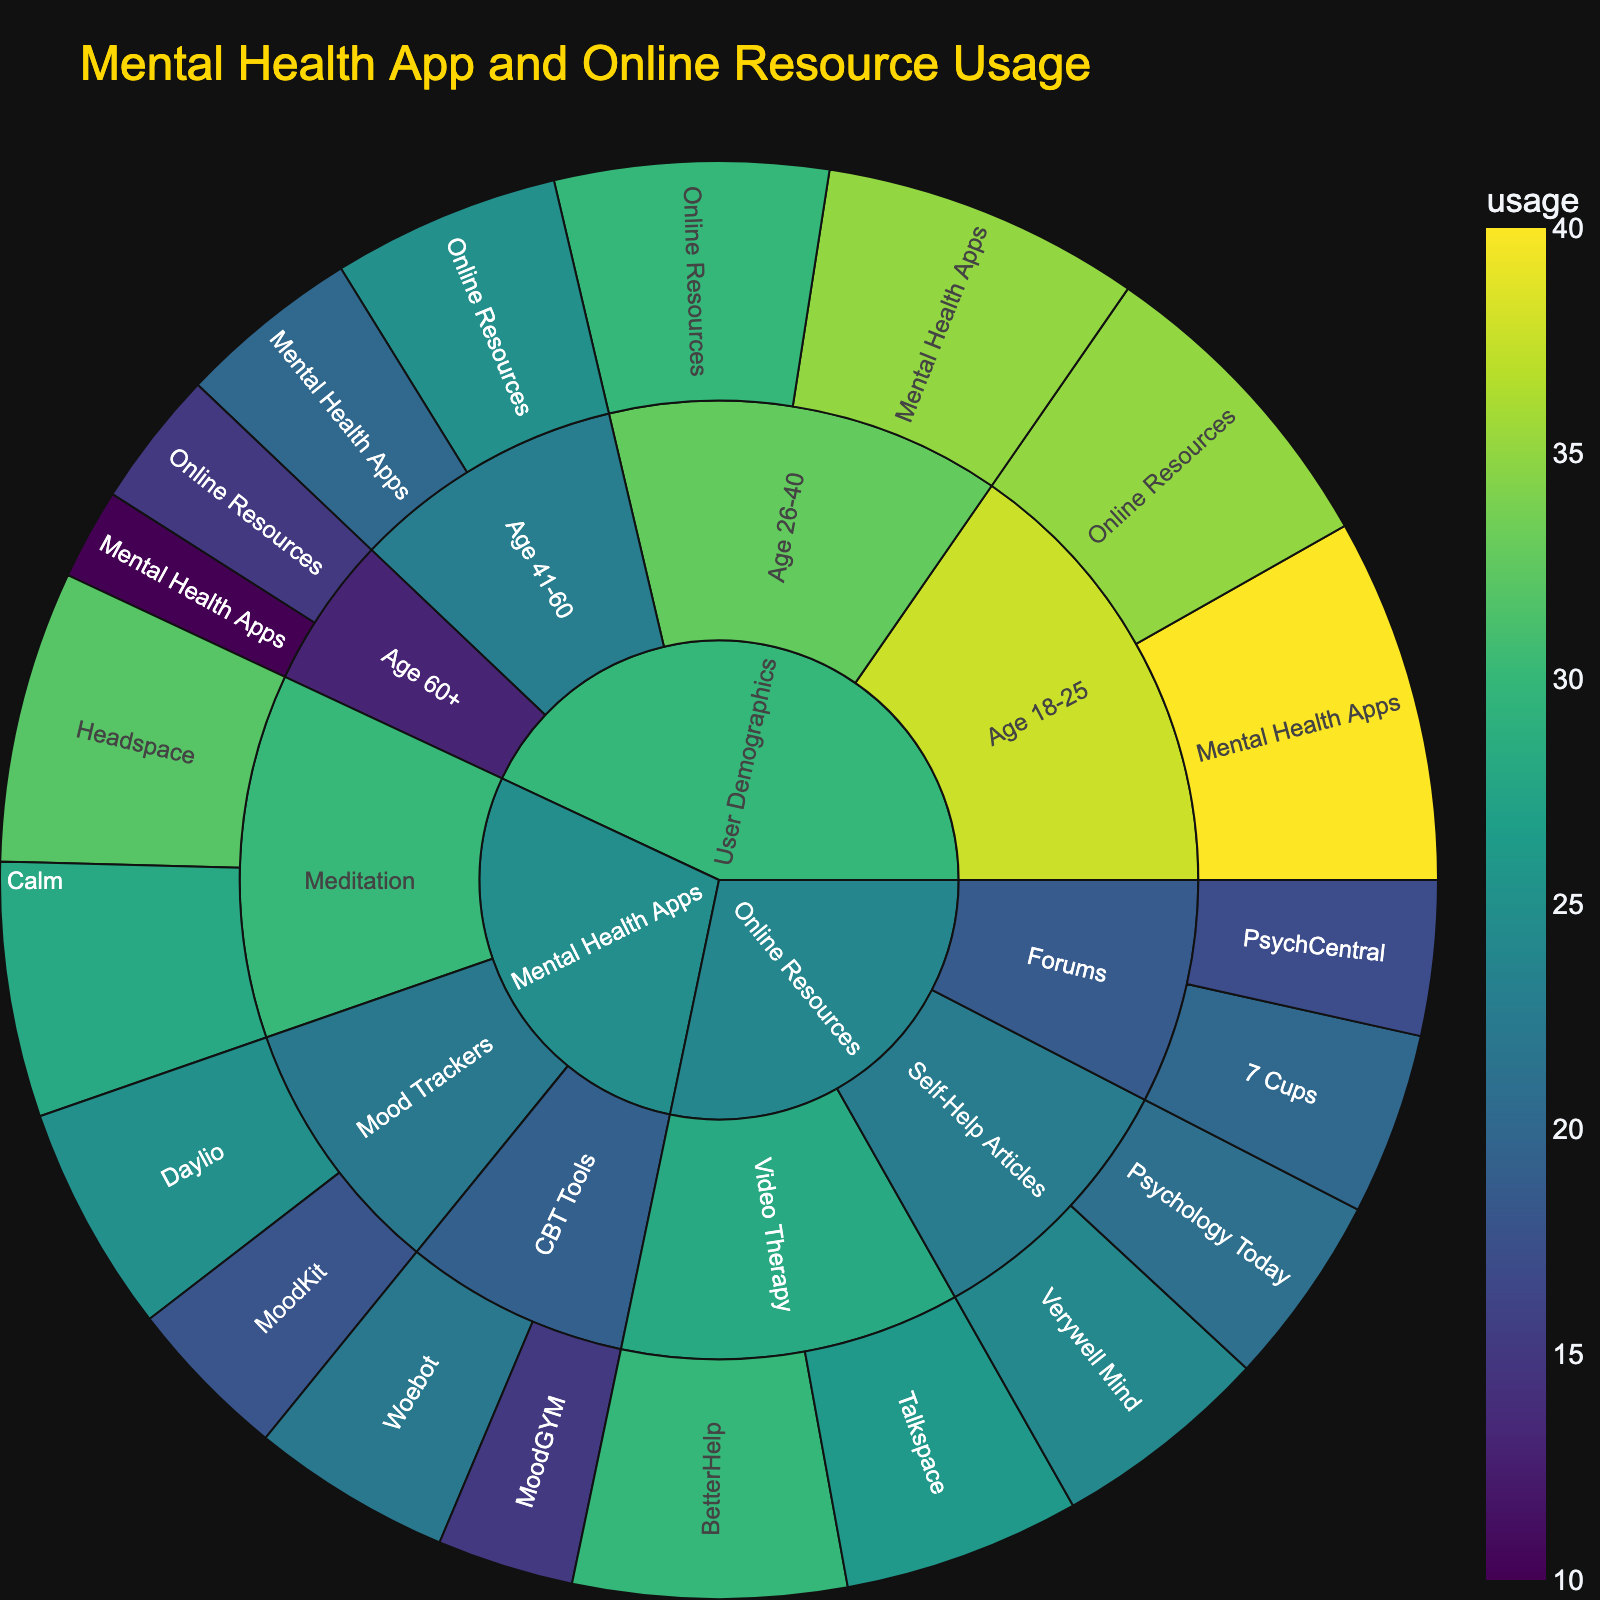What is the title of the sunburst plot? The title is usually displayed at the top of the plot and summarizes its subject matter. In this case, you can refer to the title specified within the figure.
Answer: Mental Health App and Online Resource Usage Which mental health app has the highest usage according to the plot? To find the mental health app with the highest usage, look for the subcategory “Mental Health Apps” and identify the app with the largest segment or the highest value.
Answer: Headspace What is the usage of online mental health forums combined? Sum the usage values for “7 Cups” and “PsychCentral” under the subcategory “Forums” in the online resources category. The individual values are 20 and 17, respectively. Adding these gives: 20 + 17 = 37.
Answer: 37 Compare the usage of mood trackers and CBT tools in mental health apps. Which one is greater? Identify the total usage for "Mood Trackers" by adding the usage values for "Daylio" and "MoodKit" (25 + 18). Then, sum the usage for "CBT Tools" by adding "MoodGYM" and "Woebot" (15 + 22). Finally, compare the sums: 43 > 37.
Answer: Mood Trackers Which age group has the lowest usage of mental health apps? Examine the segments under the “User Demographics” category for each age group and identify the one with the smallest value under the "Mental Health Apps" subcategory.
Answer: Age 60+ What is the combined usage of "BetterHelp" and "Talkspace"? Add the usage values for "BetterHelp" (30) and "Talkspace" (26) within the "Video Therapy" subcategory.
Answer: 56 What is the difference in usage between mental health apps and online resources for age group 18-25? Find the usage values for "Mental Health Apps" (40) and "Online Resources" (35) under the “Age 18-25” demographic. Subtract the usage of online resources from mental health apps: 40 - 35 = 5.
Answer: 5 Which category has a higher usage: “Meditation” apps or “Self-Help Articles”? Sum the usage values for “Headspace” and “Calm” under “Meditation” (32 + 28), then for “Verywell Mind” and “Psychology Today” under “Self-Help Articles” (24 + 21). Compare the sums: 60 > 45.
Answer: Meditation Which feature under "Mental Health Apps" has the highest usage? Under the "Mental Health Apps" category, compare the usage values for all features. Identify the feature with the highest value.
Answer: Headspace Is the usage of "Online Resources" greater for the age group 26-40 or 41-60? Compare the usage values for "Online Resources" under the age groups 26-40 (30) and 41-60 (25).
Answer: Age 26-40 